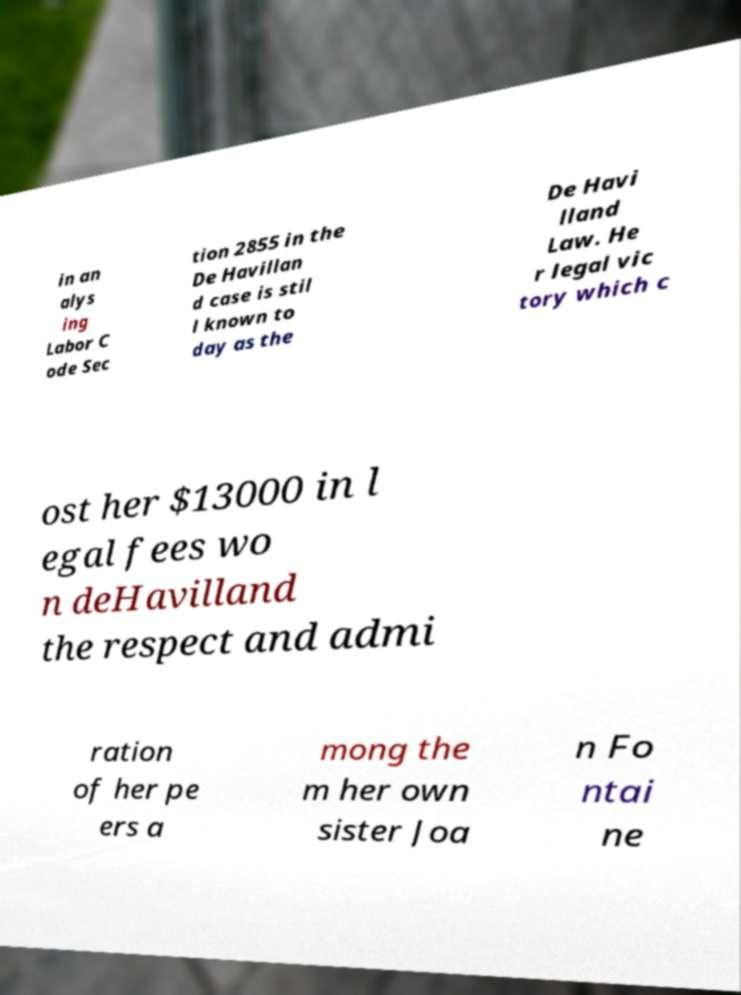What messages or text are displayed in this image? I need them in a readable, typed format. in an alys ing Labor C ode Sec tion 2855 in the De Havillan d case is stil l known to day as the De Havi lland Law. He r legal vic tory which c ost her $13000 in l egal fees wo n deHavilland the respect and admi ration of her pe ers a mong the m her own sister Joa n Fo ntai ne 